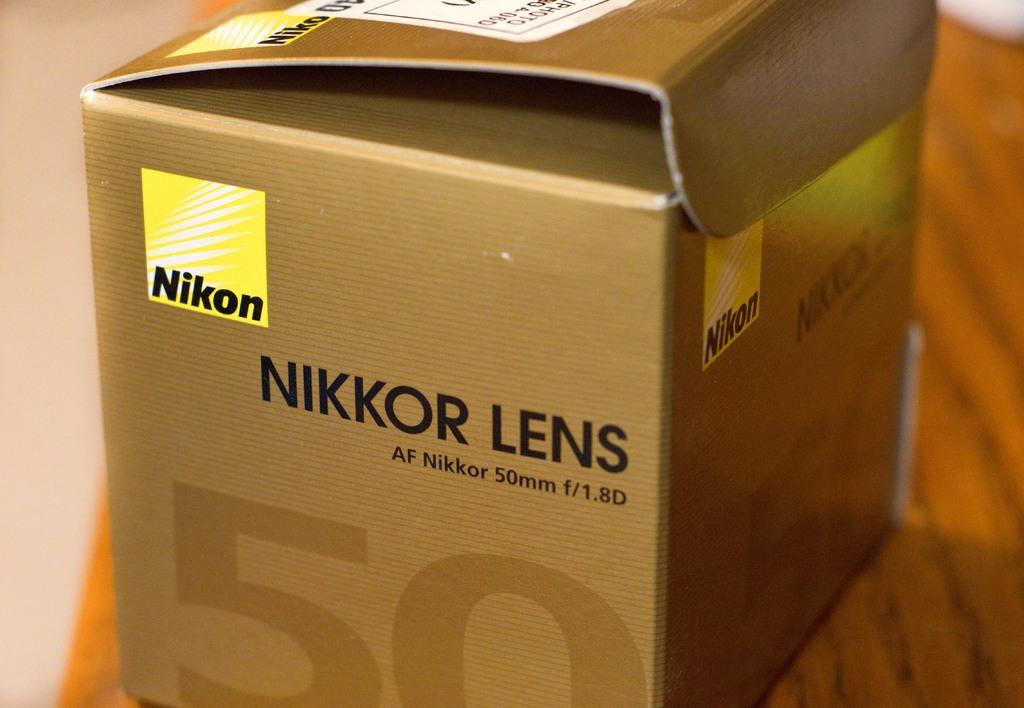What object is present in the image that could be used for storage or packaging? There is a box in the image. What type of surface is the box resting on? The box is on a wooden surface. What information is visible on the box? There is text and logos on the box. What type of knife is being used to cut the bread in the image? There is no knife or bread present in the image; it only features a box on a wooden surface with text and logos. 